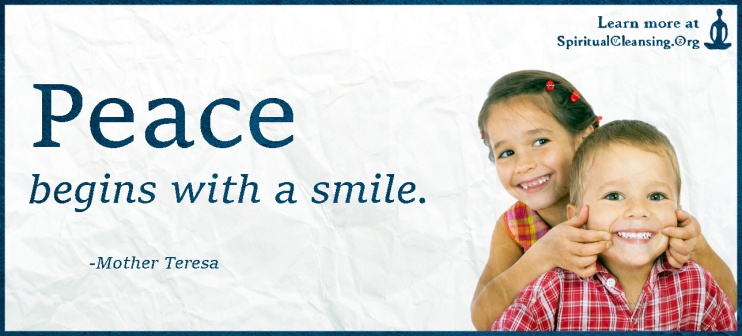Could you write a short story inspired by this image? In a small, peaceful village nestled between rolling green hills, lived two inseparable friends, Emma and Leo. Every day after school, they would race to their favorite spot—a meadow filled with wildflowers, where a large, ancient oak tree stood. The tree's branches stretched out wide, providing the perfect canopy for their adventures. One sunny afternoon, they found themselves under the oak tree once again. As they lay on the grass, looking up at the sky, Leo turned to Emma and said, 'Did you know that peace starts with a smile? That's what my grandmother always says.' Emma smiled back and replied, 'I think she's right. Smiling makes me feel warm inside.'

Suddenly, they decided to put the idea to the test. Running back to the village, they greeted everyone they met with the biggest smiles they could muster. To their delight, their smiles were contagious. The baker gave them an extra pastry, the old clockmaker shared a funny story, and children nearby joined them in a spontaneous game of tag. By the end of the day, the entire village seemed to be buzzing with a newfound happiness. That evening, as the sun set over the hills, Emma and Leo sat under the oak tree once more, content and peaceful. They had learned a powerful lesson: sometimes, the smallest gestures can create the biggest waves of joy. 